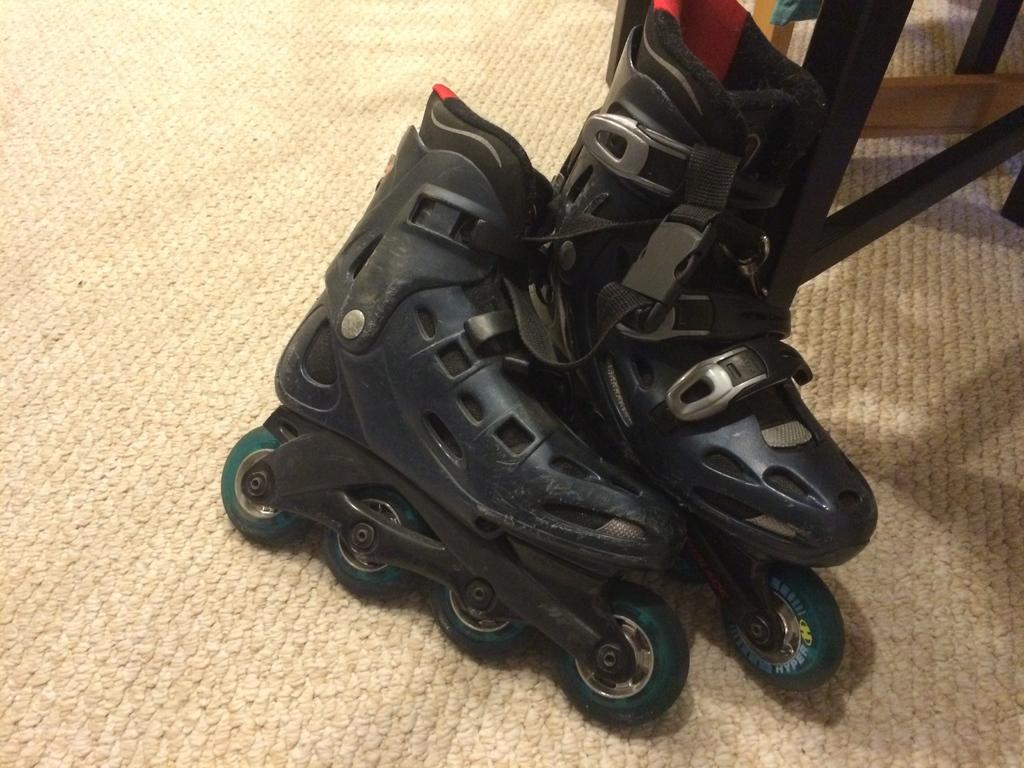What type of footwear is visible in the image? There is a pair of skating shoes in the image. What type of flooring is present in the image? There is a carpet in the image. What type of bone can be seen in the image? There is no bone present in the image. What type of yoke is visible in the image? There is no yoke present in the image. 